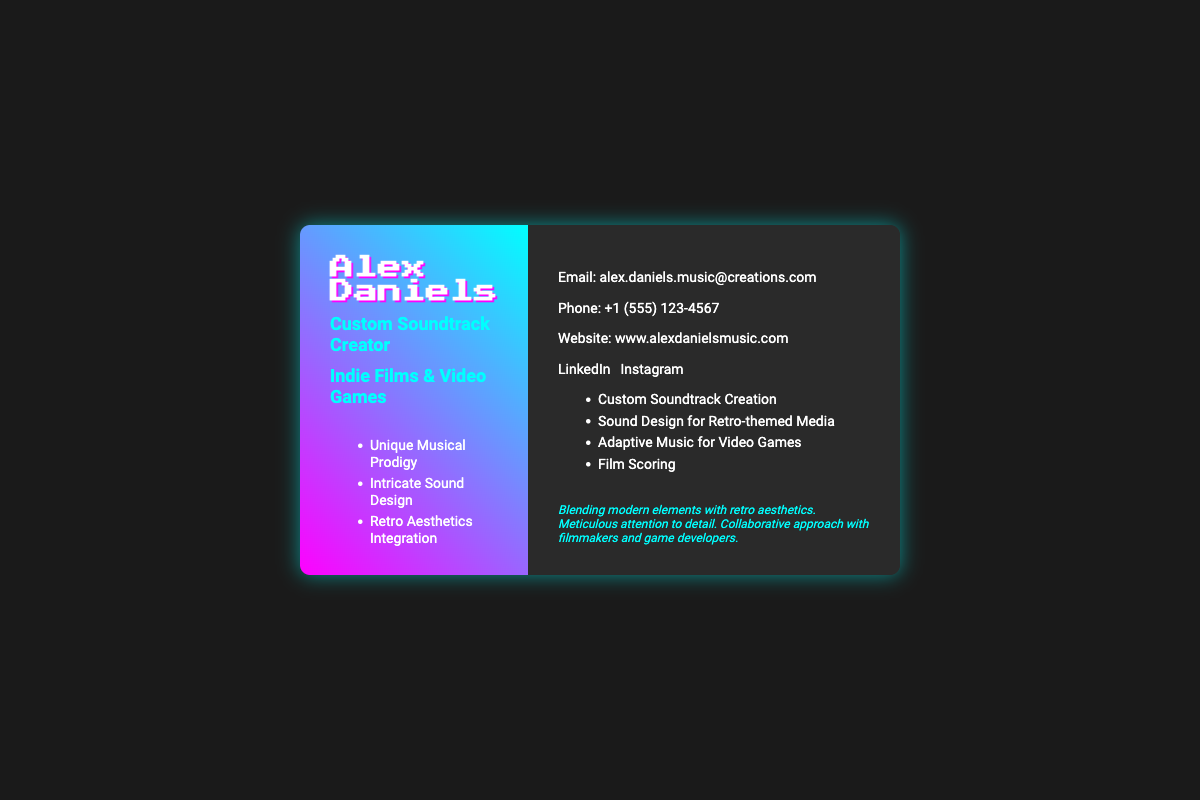What is the name of the soundtrack creator? The name of the soundtrack creator is prominently displayed at the top of the document as "Alex Daniels."
Answer: Alex Daniels What is the email address listed? The email address is clearly provided in the contact information section of the document.
Answer: alex.daniels.music@creations.com What is one of the services offered? The services offered are listed in the right-side section, where several are mentioned.
Answer: Custom Soundtrack Creation How many social media links are provided? There are two social media links mentioned in the document which can be counted easily.
Answer: 2 What is the primary focus of Alex Daniels' services? The focus is indicated by the specific titles listed on the card for the services offered.
Answer: Indie Films & Video Games What unique aspect does Alex emphasize in his work? The unique selling proposition (USP) mentions a specific combination of style and approach.
Answer: Blending modern elements with retro aesthetics What is the phone number listed? The phone number can be found in the contact information section of the business card.
Answer: +1 (555) 123-4567 Why might someone choose Alex for their project? The document outlines a collaborative approach in the USP section, showing why someone might select him.
Answer: Collaborative approach with filmmakers and game developers What type of aesthetic is emphasized in the strengths? The strengths section of the left side explicitly mentions a particular aesthetic focus.
Answer: Retro Aesthetics Integration 